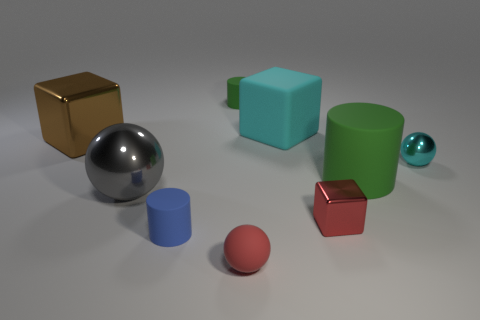Subtract all blocks. How many objects are left? 6 Add 2 large gray metallic spheres. How many large gray metallic spheres exist? 3 Subtract 0 yellow cubes. How many objects are left? 9 Subtract all red matte objects. Subtract all small matte cylinders. How many objects are left? 6 Add 7 small blue matte things. How many small blue matte things are left? 8 